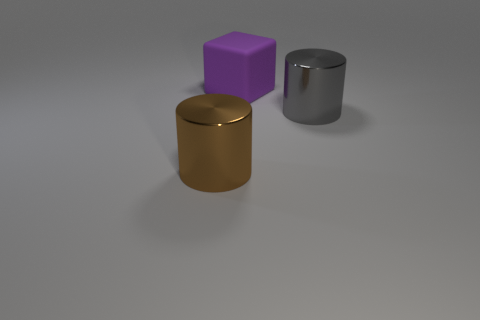Is the big cylinder that is in front of the big gray metallic cylinder made of the same material as the big thing behind the gray metallic thing? Based on the image, the cylinder in front of the large gray metallic cylinder appears to have a different color and perhaps a different finish, suggesting it may not be made of the same material. The interaction of light and the visible textures often gives clues about material composition. However, it is important to note that without further information, we cannot be completely certain about the materials as coatings and treatments can alter visual appearance. 